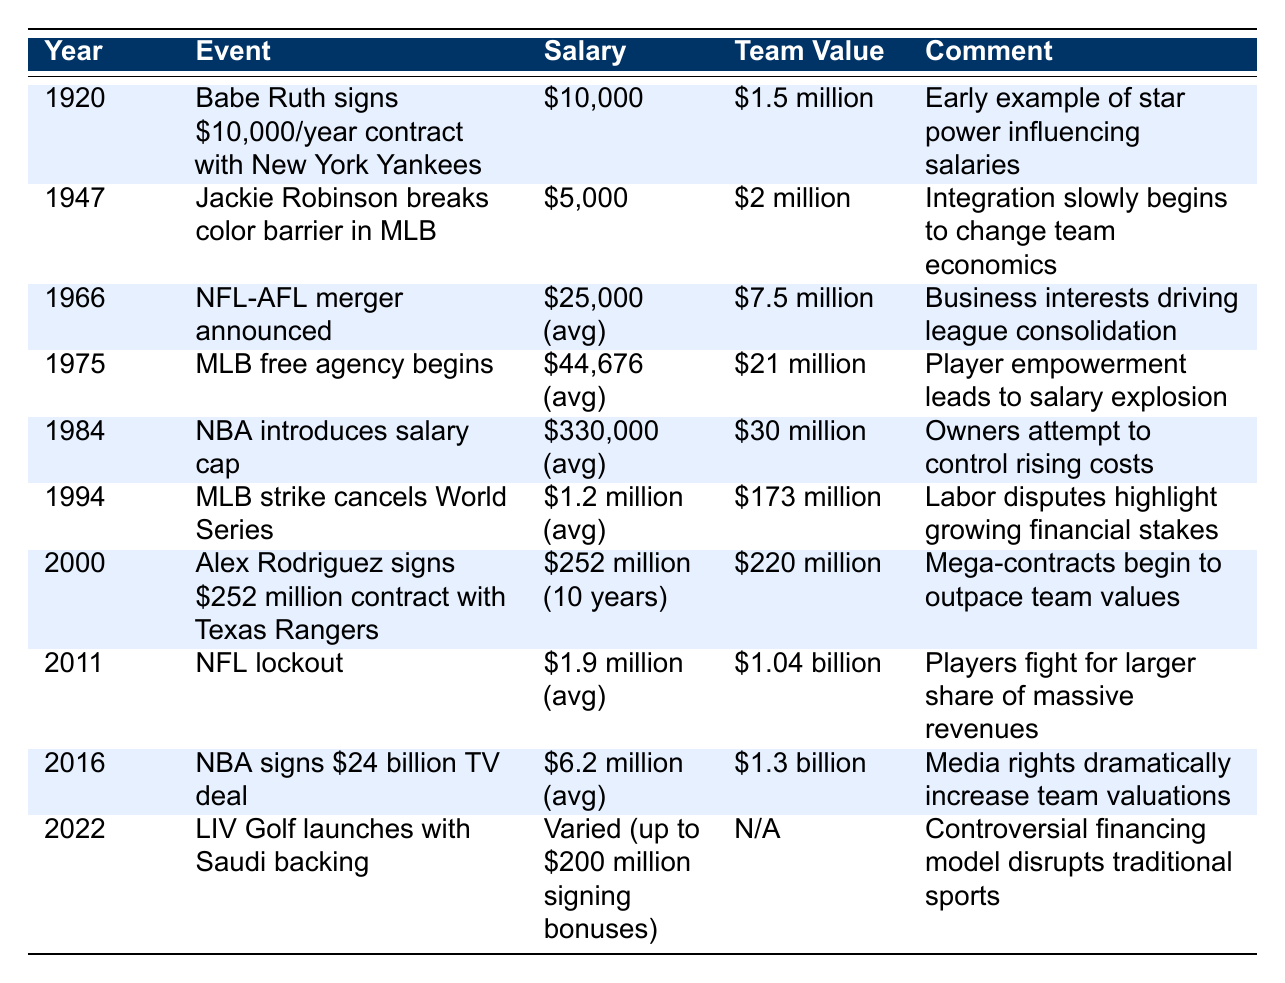What was Babe Ruth's salary when he signed with the New York Yankees in 1920? The table shows that in 1920, Babe Ruth's contract was worth $10,000 per year.
Answer: $10,000 What was the team value of MLB in 1947 when Jackie Robinson broke the color barrier? According to the table, the team value in 1947 was $2 million.
Answer: $2 million What is the average salary of players in 2011 based on the table? The table indicates that the average salary for players in 2011 was $1.9 million.
Answer: $1.9 million Did the introduction of the salary cap in the NBA in 1984 aim to control rising costs? Yes, the comment in the table mentions that owners attempted to control rising costs by introducing the salary cap.
Answer: Yes How much did the team value increase from 1975 to 1994? In 1975, the team value was $21 million, and in 1994 it was $173 million. To find the increase, subtract: $173 million - $21 million = $152 million.
Answer: $152 million What was the average salary in 1966, and how does it compare to the salary in 2016? The average salary in 1966 was $25,000, and in 2016 it was $6.2 million. To compare: $6.2 million - $25,000 = $6,175,000, indicating a significant increase.
Answer: $6,175,000 Was the contract of Alex Rodriguez in 2000 larger than the team value of the Texas Rangers at that time? Yes, the table states that Alex Rodriguez's contract was $252 million, while the team value was $220 million, which means the contract exceeded the team value.
Answer: Yes What was the salary advantage of players during the MLB free agency in 1975 compared to the previous year? The average salary in 1975 was $44,676. In the previous year (the exact figure is not provided), we cannot make a direct comparison, as the table does not show salaries for 1974. This question can't be answered with certainty from the available data.
Answer: Cannot determine How many years passed from Babe Ruth’s contract signing to the introduction of the salary cap in the NBA? Babe Ruth signed his contract in 1920, and the salary cap was introduced in 1984. To find the difference: 1984 - 1920 = 64 years.
Answer: 64 years What was the trend in team valuations from the year 2000 to 2016? The team value increased from $220 million in 2000 to $1.3 billion in 2016, indicating a significant upward trend in valuations during that period. To summarize, the analysis shows growth attributed to rising media rights.
Answer: Significant increase 